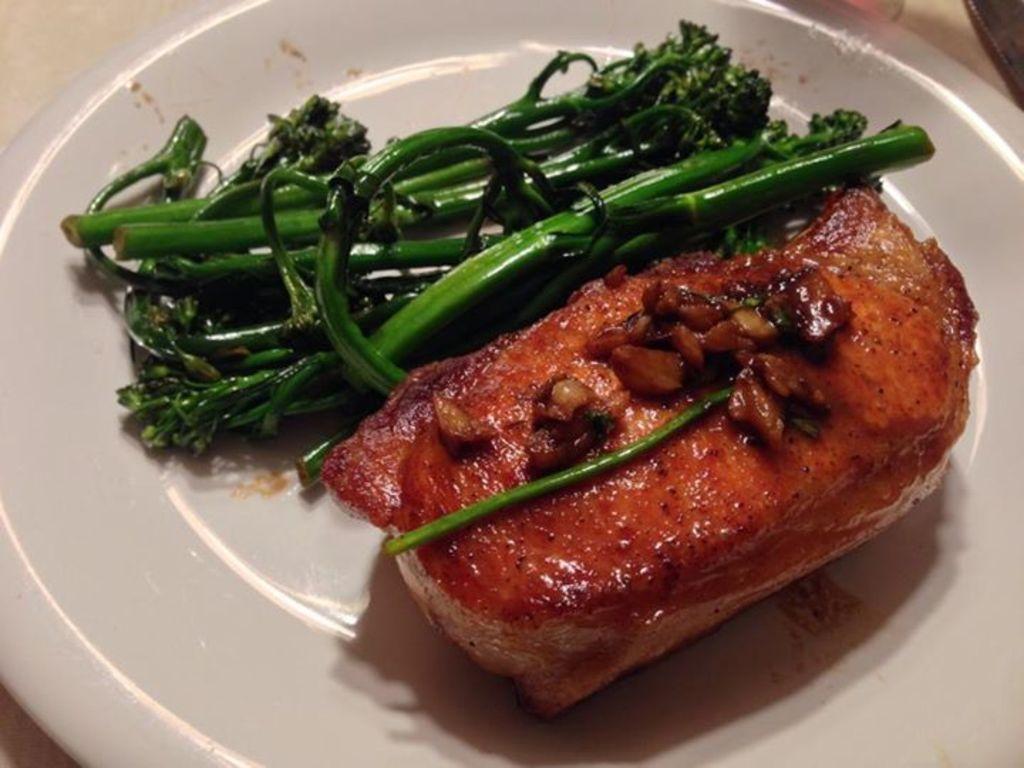Please provide a concise description of this image. This image consists of a white color plate. On the plate I can see two different food items which are in green and red colors. 